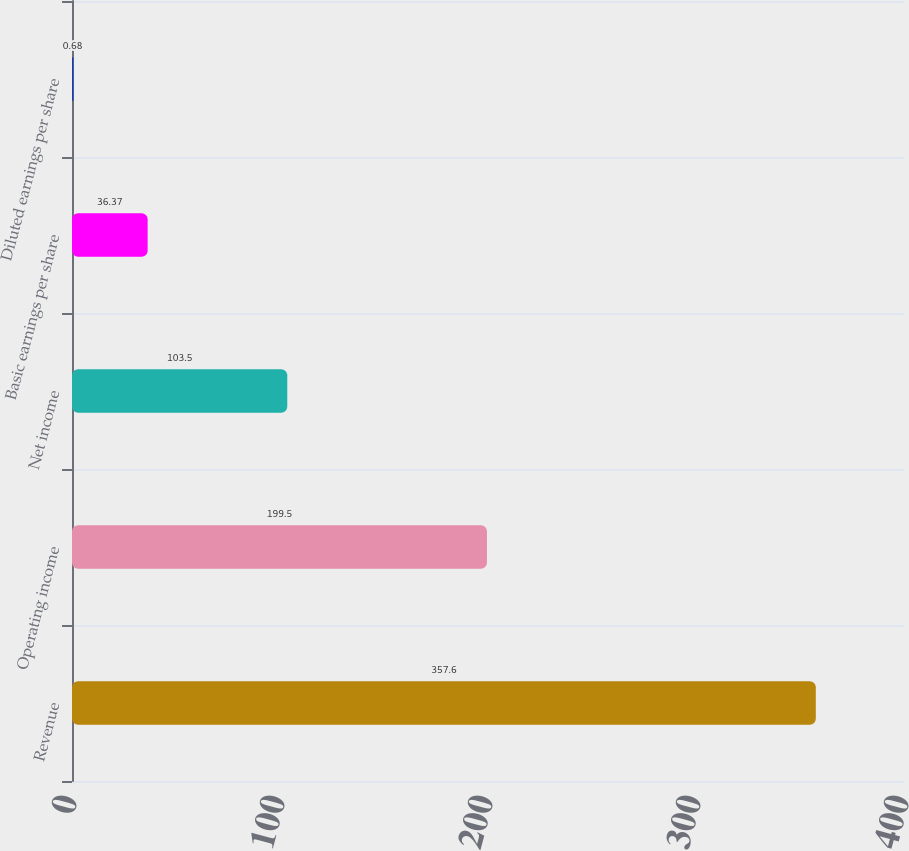Convert chart to OTSL. <chart><loc_0><loc_0><loc_500><loc_500><bar_chart><fcel>Revenue<fcel>Operating income<fcel>Net income<fcel>Basic earnings per share<fcel>Diluted earnings per share<nl><fcel>357.6<fcel>199.5<fcel>103.5<fcel>36.37<fcel>0.68<nl></chart> 